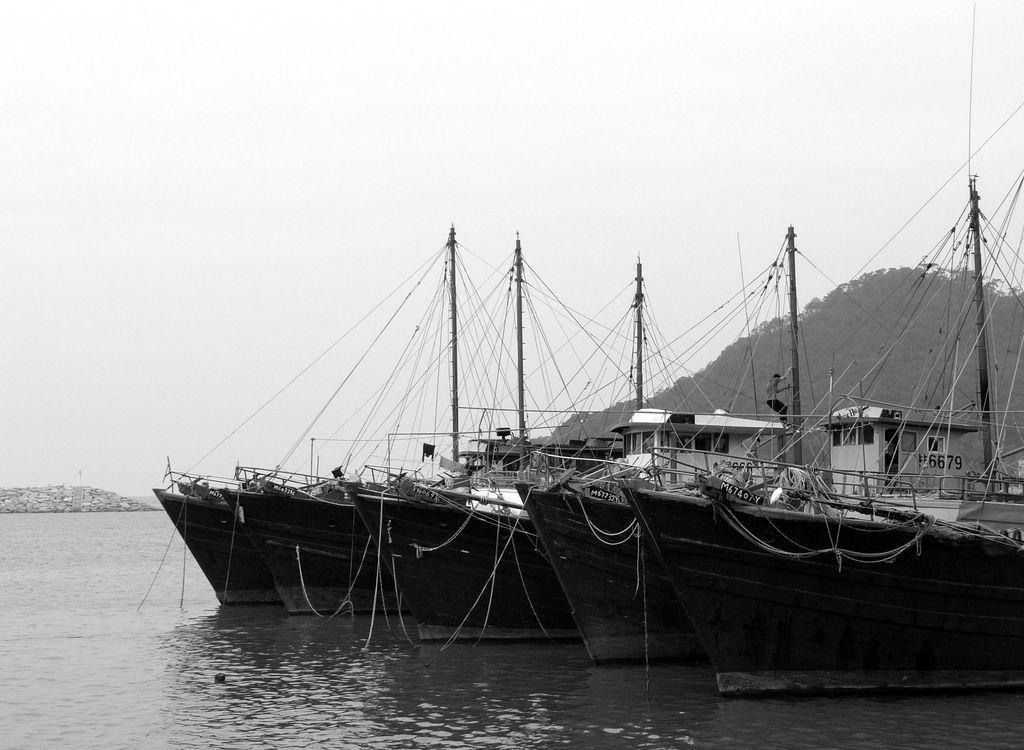In one or two sentences, can you explain what this image depicts? This is a black and white image and here we can see ships, sheds, stones and there is a hill and trees. At the bottom, there is water and at the top, there is sky. 